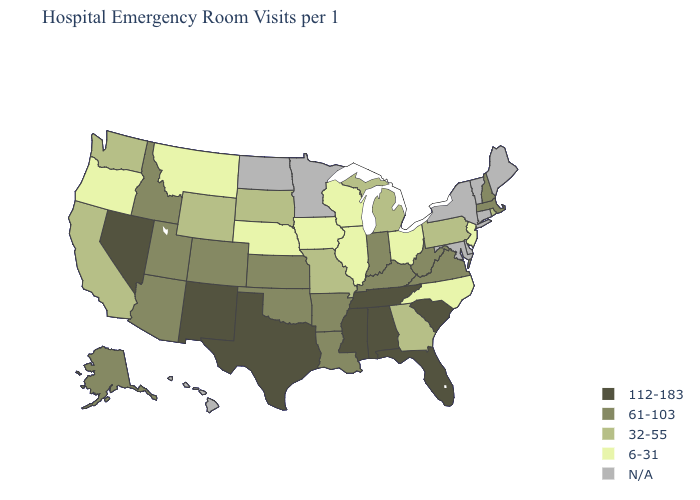Name the states that have a value in the range 32-55?
Answer briefly. California, Georgia, Michigan, Missouri, Pennsylvania, Rhode Island, South Dakota, Washington, Wyoming. Name the states that have a value in the range 61-103?
Keep it brief. Alaska, Arizona, Arkansas, Colorado, Idaho, Indiana, Kansas, Kentucky, Louisiana, Massachusetts, New Hampshire, Oklahoma, Utah, Virginia, West Virginia. Which states have the highest value in the USA?
Write a very short answer. Alabama, Florida, Mississippi, Nevada, New Mexico, South Carolina, Tennessee, Texas. What is the lowest value in the South?
Keep it brief. 6-31. Which states hav the highest value in the South?
Concise answer only. Alabama, Florida, Mississippi, South Carolina, Tennessee, Texas. Is the legend a continuous bar?
Concise answer only. No. Name the states that have a value in the range 61-103?
Quick response, please. Alaska, Arizona, Arkansas, Colorado, Idaho, Indiana, Kansas, Kentucky, Louisiana, Massachusetts, New Hampshire, Oklahoma, Utah, Virginia, West Virginia. Does the first symbol in the legend represent the smallest category?
Answer briefly. No. Which states have the highest value in the USA?
Write a very short answer. Alabama, Florida, Mississippi, Nevada, New Mexico, South Carolina, Tennessee, Texas. How many symbols are there in the legend?
Give a very brief answer. 5. Which states have the lowest value in the MidWest?
Write a very short answer. Illinois, Iowa, Nebraska, Ohio, Wisconsin. Among the states that border North Dakota , which have the highest value?
Concise answer only. South Dakota. Name the states that have a value in the range 61-103?
Give a very brief answer. Alaska, Arizona, Arkansas, Colorado, Idaho, Indiana, Kansas, Kentucky, Louisiana, Massachusetts, New Hampshire, Oklahoma, Utah, Virginia, West Virginia. Name the states that have a value in the range 32-55?
Be succinct. California, Georgia, Michigan, Missouri, Pennsylvania, Rhode Island, South Dakota, Washington, Wyoming. 